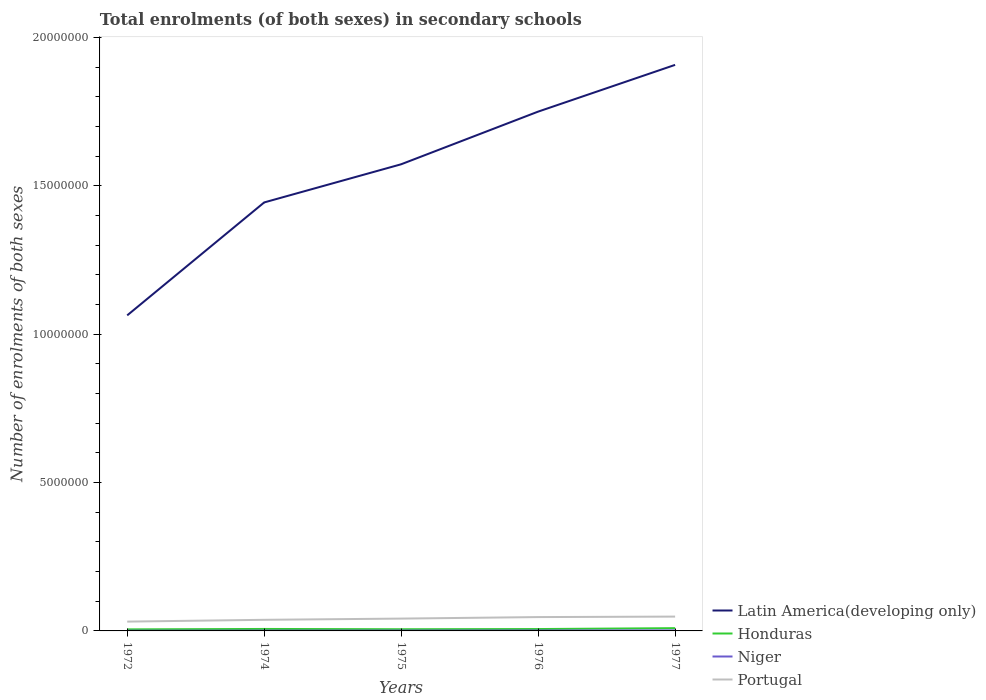How many different coloured lines are there?
Give a very brief answer. 4. Does the line corresponding to Portugal intersect with the line corresponding to Latin America(developing only)?
Offer a terse response. No. Across all years, what is the maximum number of enrolments in secondary schools in Latin America(developing only)?
Provide a short and direct response. 1.06e+07. In which year was the number of enrolments in secondary schools in Latin America(developing only) maximum?
Ensure brevity in your answer.  1972. What is the total number of enrolments in secondary schools in Niger in the graph?
Make the answer very short. -4358. What is the difference between the highest and the second highest number of enrolments in secondary schools in Niger?
Provide a short and direct response. 1.01e+04. What is the difference between the highest and the lowest number of enrolments in secondary schools in Latin America(developing only)?
Provide a short and direct response. 3. Is the number of enrolments in secondary schools in Latin America(developing only) strictly greater than the number of enrolments in secondary schools in Niger over the years?
Give a very brief answer. No. How many lines are there?
Provide a short and direct response. 4. Does the graph contain any zero values?
Give a very brief answer. No. Does the graph contain grids?
Provide a succinct answer. No. Where does the legend appear in the graph?
Provide a short and direct response. Bottom right. How are the legend labels stacked?
Provide a short and direct response. Vertical. What is the title of the graph?
Provide a short and direct response. Total enrolments (of both sexes) in secondary schools. What is the label or title of the X-axis?
Your answer should be compact. Years. What is the label or title of the Y-axis?
Provide a short and direct response. Number of enrolments of both sexes. What is the Number of enrolments of both sexes in Latin America(developing only) in 1972?
Ensure brevity in your answer.  1.06e+07. What is the Number of enrolments of both sexes of Honduras in 1972?
Offer a very short reply. 5.23e+04. What is the Number of enrolments of both sexes in Niger in 1972?
Your answer should be very brief. 7975. What is the Number of enrolments of both sexes of Portugal in 1972?
Provide a short and direct response. 3.14e+05. What is the Number of enrolments of both sexes in Latin America(developing only) in 1974?
Provide a short and direct response. 1.44e+07. What is the Number of enrolments of both sexes of Honduras in 1974?
Keep it short and to the point. 6.64e+04. What is the Number of enrolments of both sexes in Niger in 1974?
Provide a short and direct response. 1.11e+04. What is the Number of enrolments of both sexes of Portugal in 1974?
Offer a very short reply. 3.74e+05. What is the Number of enrolments of both sexes of Latin America(developing only) in 1975?
Your response must be concise. 1.57e+07. What is the Number of enrolments of both sexes of Honduras in 1975?
Make the answer very short. 5.67e+04. What is the Number of enrolments of both sexes in Niger in 1975?
Ensure brevity in your answer.  1.23e+04. What is the Number of enrolments of both sexes in Portugal in 1975?
Ensure brevity in your answer.  4.16e+05. What is the Number of enrolments of both sexes in Latin America(developing only) in 1976?
Give a very brief answer. 1.75e+07. What is the Number of enrolments of both sexes in Honduras in 1976?
Your response must be concise. 6.31e+04. What is the Number of enrolments of both sexes in Niger in 1976?
Ensure brevity in your answer.  1.45e+04. What is the Number of enrolments of both sexes in Portugal in 1976?
Ensure brevity in your answer.  4.66e+05. What is the Number of enrolments of both sexes in Latin America(developing only) in 1977?
Keep it short and to the point. 1.91e+07. What is the Number of enrolments of both sexes of Honduras in 1977?
Offer a terse response. 9.33e+04. What is the Number of enrolments of both sexes of Niger in 1977?
Your response must be concise. 1.81e+04. What is the Number of enrolments of both sexes of Portugal in 1977?
Keep it short and to the point. 4.83e+05. Across all years, what is the maximum Number of enrolments of both sexes in Latin America(developing only)?
Offer a terse response. 1.91e+07. Across all years, what is the maximum Number of enrolments of both sexes of Honduras?
Keep it short and to the point. 9.33e+04. Across all years, what is the maximum Number of enrolments of both sexes in Niger?
Provide a succinct answer. 1.81e+04. Across all years, what is the maximum Number of enrolments of both sexes in Portugal?
Provide a short and direct response. 4.83e+05. Across all years, what is the minimum Number of enrolments of both sexes of Latin America(developing only)?
Your response must be concise. 1.06e+07. Across all years, what is the minimum Number of enrolments of both sexes of Honduras?
Offer a very short reply. 5.23e+04. Across all years, what is the minimum Number of enrolments of both sexes of Niger?
Provide a succinct answer. 7975. Across all years, what is the minimum Number of enrolments of both sexes in Portugal?
Offer a terse response. 3.14e+05. What is the total Number of enrolments of both sexes in Latin America(developing only) in the graph?
Offer a very short reply. 7.74e+07. What is the total Number of enrolments of both sexes in Honduras in the graph?
Provide a succinct answer. 3.32e+05. What is the total Number of enrolments of both sexes of Niger in the graph?
Your response must be concise. 6.40e+04. What is the total Number of enrolments of both sexes of Portugal in the graph?
Your answer should be compact. 2.05e+06. What is the difference between the Number of enrolments of both sexes in Latin America(developing only) in 1972 and that in 1974?
Ensure brevity in your answer.  -3.81e+06. What is the difference between the Number of enrolments of both sexes in Honduras in 1972 and that in 1974?
Offer a terse response. -1.41e+04. What is the difference between the Number of enrolments of both sexes of Niger in 1972 and that in 1974?
Provide a succinct answer. -3133. What is the difference between the Number of enrolments of both sexes of Portugal in 1972 and that in 1974?
Ensure brevity in your answer.  -6.01e+04. What is the difference between the Number of enrolments of both sexes of Latin America(developing only) in 1972 and that in 1975?
Offer a terse response. -5.09e+06. What is the difference between the Number of enrolments of both sexes of Honduras in 1972 and that in 1975?
Offer a terse response. -4380. What is the difference between the Number of enrolments of both sexes of Niger in 1972 and that in 1975?
Your answer should be compact. -4358. What is the difference between the Number of enrolments of both sexes of Portugal in 1972 and that in 1975?
Your response must be concise. -1.02e+05. What is the difference between the Number of enrolments of both sexes in Latin America(developing only) in 1972 and that in 1976?
Your answer should be very brief. -6.87e+06. What is the difference between the Number of enrolments of both sexes of Honduras in 1972 and that in 1976?
Provide a short and direct response. -1.08e+04. What is the difference between the Number of enrolments of both sexes in Niger in 1972 and that in 1976?
Make the answer very short. -6487. What is the difference between the Number of enrolments of both sexes in Portugal in 1972 and that in 1976?
Your answer should be very brief. -1.52e+05. What is the difference between the Number of enrolments of both sexes of Latin America(developing only) in 1972 and that in 1977?
Provide a short and direct response. -8.44e+06. What is the difference between the Number of enrolments of both sexes in Honduras in 1972 and that in 1977?
Make the answer very short. -4.10e+04. What is the difference between the Number of enrolments of both sexes of Niger in 1972 and that in 1977?
Provide a short and direct response. -1.01e+04. What is the difference between the Number of enrolments of both sexes of Portugal in 1972 and that in 1977?
Your response must be concise. -1.69e+05. What is the difference between the Number of enrolments of both sexes in Latin America(developing only) in 1974 and that in 1975?
Keep it short and to the point. -1.29e+06. What is the difference between the Number of enrolments of both sexes of Honduras in 1974 and that in 1975?
Offer a terse response. 9706. What is the difference between the Number of enrolments of both sexes in Niger in 1974 and that in 1975?
Your answer should be compact. -1225. What is the difference between the Number of enrolments of both sexes in Portugal in 1974 and that in 1975?
Your answer should be very brief. -4.15e+04. What is the difference between the Number of enrolments of both sexes in Latin America(developing only) in 1974 and that in 1976?
Keep it short and to the point. -3.06e+06. What is the difference between the Number of enrolments of both sexes in Honduras in 1974 and that in 1976?
Your response must be concise. 3296. What is the difference between the Number of enrolments of both sexes of Niger in 1974 and that in 1976?
Offer a terse response. -3354. What is the difference between the Number of enrolments of both sexes in Portugal in 1974 and that in 1976?
Offer a terse response. -9.24e+04. What is the difference between the Number of enrolments of both sexes in Latin America(developing only) in 1974 and that in 1977?
Give a very brief answer. -4.64e+06. What is the difference between the Number of enrolments of both sexes of Honduras in 1974 and that in 1977?
Give a very brief answer. -2.69e+04. What is the difference between the Number of enrolments of both sexes in Niger in 1974 and that in 1977?
Offer a very short reply. -6990. What is the difference between the Number of enrolments of both sexes in Portugal in 1974 and that in 1977?
Keep it short and to the point. -1.08e+05. What is the difference between the Number of enrolments of both sexes of Latin America(developing only) in 1975 and that in 1976?
Your response must be concise. -1.77e+06. What is the difference between the Number of enrolments of both sexes of Honduras in 1975 and that in 1976?
Ensure brevity in your answer.  -6410. What is the difference between the Number of enrolments of both sexes of Niger in 1975 and that in 1976?
Provide a succinct answer. -2129. What is the difference between the Number of enrolments of both sexes of Portugal in 1975 and that in 1976?
Offer a very short reply. -5.08e+04. What is the difference between the Number of enrolments of both sexes in Latin America(developing only) in 1975 and that in 1977?
Your answer should be compact. -3.35e+06. What is the difference between the Number of enrolments of both sexes of Honduras in 1975 and that in 1977?
Offer a terse response. -3.66e+04. What is the difference between the Number of enrolments of both sexes of Niger in 1975 and that in 1977?
Ensure brevity in your answer.  -5765. What is the difference between the Number of enrolments of both sexes of Portugal in 1975 and that in 1977?
Ensure brevity in your answer.  -6.69e+04. What is the difference between the Number of enrolments of both sexes of Latin America(developing only) in 1976 and that in 1977?
Your response must be concise. -1.58e+06. What is the difference between the Number of enrolments of both sexes of Honduras in 1976 and that in 1977?
Your response must be concise. -3.02e+04. What is the difference between the Number of enrolments of both sexes of Niger in 1976 and that in 1977?
Ensure brevity in your answer.  -3636. What is the difference between the Number of enrolments of both sexes in Portugal in 1976 and that in 1977?
Provide a succinct answer. -1.61e+04. What is the difference between the Number of enrolments of both sexes of Latin America(developing only) in 1972 and the Number of enrolments of both sexes of Honduras in 1974?
Make the answer very short. 1.06e+07. What is the difference between the Number of enrolments of both sexes in Latin America(developing only) in 1972 and the Number of enrolments of both sexes in Niger in 1974?
Provide a succinct answer. 1.06e+07. What is the difference between the Number of enrolments of both sexes of Latin America(developing only) in 1972 and the Number of enrolments of both sexes of Portugal in 1974?
Keep it short and to the point. 1.03e+07. What is the difference between the Number of enrolments of both sexes in Honduras in 1972 and the Number of enrolments of both sexes in Niger in 1974?
Keep it short and to the point. 4.12e+04. What is the difference between the Number of enrolments of both sexes of Honduras in 1972 and the Number of enrolments of both sexes of Portugal in 1974?
Make the answer very short. -3.22e+05. What is the difference between the Number of enrolments of both sexes of Niger in 1972 and the Number of enrolments of both sexes of Portugal in 1974?
Give a very brief answer. -3.66e+05. What is the difference between the Number of enrolments of both sexes of Latin America(developing only) in 1972 and the Number of enrolments of both sexes of Honduras in 1975?
Your answer should be very brief. 1.06e+07. What is the difference between the Number of enrolments of both sexes of Latin America(developing only) in 1972 and the Number of enrolments of both sexes of Niger in 1975?
Your answer should be very brief. 1.06e+07. What is the difference between the Number of enrolments of both sexes in Latin America(developing only) in 1972 and the Number of enrolments of both sexes in Portugal in 1975?
Provide a succinct answer. 1.02e+07. What is the difference between the Number of enrolments of both sexes of Honduras in 1972 and the Number of enrolments of both sexes of Niger in 1975?
Your response must be concise. 4.00e+04. What is the difference between the Number of enrolments of both sexes of Honduras in 1972 and the Number of enrolments of both sexes of Portugal in 1975?
Provide a succinct answer. -3.63e+05. What is the difference between the Number of enrolments of both sexes of Niger in 1972 and the Number of enrolments of both sexes of Portugal in 1975?
Provide a succinct answer. -4.08e+05. What is the difference between the Number of enrolments of both sexes in Latin America(developing only) in 1972 and the Number of enrolments of both sexes in Honduras in 1976?
Your answer should be very brief. 1.06e+07. What is the difference between the Number of enrolments of both sexes in Latin America(developing only) in 1972 and the Number of enrolments of both sexes in Niger in 1976?
Your answer should be very brief. 1.06e+07. What is the difference between the Number of enrolments of both sexes of Latin America(developing only) in 1972 and the Number of enrolments of both sexes of Portugal in 1976?
Keep it short and to the point. 1.02e+07. What is the difference between the Number of enrolments of both sexes in Honduras in 1972 and the Number of enrolments of both sexes in Niger in 1976?
Offer a very short reply. 3.79e+04. What is the difference between the Number of enrolments of both sexes of Honduras in 1972 and the Number of enrolments of both sexes of Portugal in 1976?
Make the answer very short. -4.14e+05. What is the difference between the Number of enrolments of both sexes of Niger in 1972 and the Number of enrolments of both sexes of Portugal in 1976?
Your answer should be very brief. -4.59e+05. What is the difference between the Number of enrolments of both sexes in Latin America(developing only) in 1972 and the Number of enrolments of both sexes in Honduras in 1977?
Offer a very short reply. 1.05e+07. What is the difference between the Number of enrolments of both sexes in Latin America(developing only) in 1972 and the Number of enrolments of both sexes in Niger in 1977?
Make the answer very short. 1.06e+07. What is the difference between the Number of enrolments of both sexes in Latin America(developing only) in 1972 and the Number of enrolments of both sexes in Portugal in 1977?
Keep it short and to the point. 1.02e+07. What is the difference between the Number of enrolments of both sexes in Honduras in 1972 and the Number of enrolments of both sexes in Niger in 1977?
Make the answer very short. 3.42e+04. What is the difference between the Number of enrolments of both sexes of Honduras in 1972 and the Number of enrolments of both sexes of Portugal in 1977?
Your answer should be compact. -4.30e+05. What is the difference between the Number of enrolments of both sexes of Niger in 1972 and the Number of enrolments of both sexes of Portugal in 1977?
Give a very brief answer. -4.75e+05. What is the difference between the Number of enrolments of both sexes in Latin America(developing only) in 1974 and the Number of enrolments of both sexes in Honduras in 1975?
Provide a succinct answer. 1.44e+07. What is the difference between the Number of enrolments of both sexes of Latin America(developing only) in 1974 and the Number of enrolments of both sexes of Niger in 1975?
Your answer should be very brief. 1.44e+07. What is the difference between the Number of enrolments of both sexes of Latin America(developing only) in 1974 and the Number of enrolments of both sexes of Portugal in 1975?
Make the answer very short. 1.40e+07. What is the difference between the Number of enrolments of both sexes of Honduras in 1974 and the Number of enrolments of both sexes of Niger in 1975?
Offer a terse response. 5.41e+04. What is the difference between the Number of enrolments of both sexes of Honduras in 1974 and the Number of enrolments of both sexes of Portugal in 1975?
Your answer should be very brief. -3.49e+05. What is the difference between the Number of enrolments of both sexes in Niger in 1974 and the Number of enrolments of both sexes in Portugal in 1975?
Offer a terse response. -4.05e+05. What is the difference between the Number of enrolments of both sexes in Latin America(developing only) in 1974 and the Number of enrolments of both sexes in Honduras in 1976?
Your answer should be compact. 1.44e+07. What is the difference between the Number of enrolments of both sexes of Latin America(developing only) in 1974 and the Number of enrolments of both sexes of Niger in 1976?
Offer a very short reply. 1.44e+07. What is the difference between the Number of enrolments of both sexes in Latin America(developing only) in 1974 and the Number of enrolments of both sexes in Portugal in 1976?
Offer a very short reply. 1.40e+07. What is the difference between the Number of enrolments of both sexes of Honduras in 1974 and the Number of enrolments of both sexes of Niger in 1976?
Provide a short and direct response. 5.19e+04. What is the difference between the Number of enrolments of both sexes of Honduras in 1974 and the Number of enrolments of both sexes of Portugal in 1976?
Provide a short and direct response. -4.00e+05. What is the difference between the Number of enrolments of both sexes of Niger in 1974 and the Number of enrolments of both sexes of Portugal in 1976?
Ensure brevity in your answer.  -4.55e+05. What is the difference between the Number of enrolments of both sexes in Latin America(developing only) in 1974 and the Number of enrolments of both sexes in Honduras in 1977?
Make the answer very short. 1.43e+07. What is the difference between the Number of enrolments of both sexes in Latin America(developing only) in 1974 and the Number of enrolments of both sexes in Niger in 1977?
Your answer should be compact. 1.44e+07. What is the difference between the Number of enrolments of both sexes of Latin America(developing only) in 1974 and the Number of enrolments of both sexes of Portugal in 1977?
Your response must be concise. 1.40e+07. What is the difference between the Number of enrolments of both sexes of Honduras in 1974 and the Number of enrolments of both sexes of Niger in 1977?
Your response must be concise. 4.83e+04. What is the difference between the Number of enrolments of both sexes in Honduras in 1974 and the Number of enrolments of both sexes in Portugal in 1977?
Your response must be concise. -4.16e+05. What is the difference between the Number of enrolments of both sexes in Niger in 1974 and the Number of enrolments of both sexes in Portugal in 1977?
Give a very brief answer. -4.71e+05. What is the difference between the Number of enrolments of both sexes in Latin America(developing only) in 1975 and the Number of enrolments of both sexes in Honduras in 1976?
Provide a short and direct response. 1.57e+07. What is the difference between the Number of enrolments of both sexes of Latin America(developing only) in 1975 and the Number of enrolments of both sexes of Niger in 1976?
Keep it short and to the point. 1.57e+07. What is the difference between the Number of enrolments of both sexes of Latin America(developing only) in 1975 and the Number of enrolments of both sexes of Portugal in 1976?
Keep it short and to the point. 1.53e+07. What is the difference between the Number of enrolments of both sexes in Honduras in 1975 and the Number of enrolments of both sexes in Niger in 1976?
Offer a terse response. 4.22e+04. What is the difference between the Number of enrolments of both sexes of Honduras in 1975 and the Number of enrolments of both sexes of Portugal in 1976?
Your response must be concise. -4.10e+05. What is the difference between the Number of enrolments of both sexes of Niger in 1975 and the Number of enrolments of both sexes of Portugal in 1976?
Ensure brevity in your answer.  -4.54e+05. What is the difference between the Number of enrolments of both sexes in Latin America(developing only) in 1975 and the Number of enrolments of both sexes in Honduras in 1977?
Keep it short and to the point. 1.56e+07. What is the difference between the Number of enrolments of both sexes in Latin America(developing only) in 1975 and the Number of enrolments of both sexes in Niger in 1977?
Offer a very short reply. 1.57e+07. What is the difference between the Number of enrolments of both sexes in Latin America(developing only) in 1975 and the Number of enrolments of both sexes in Portugal in 1977?
Your response must be concise. 1.52e+07. What is the difference between the Number of enrolments of both sexes of Honduras in 1975 and the Number of enrolments of both sexes of Niger in 1977?
Your answer should be compact. 3.86e+04. What is the difference between the Number of enrolments of both sexes in Honduras in 1975 and the Number of enrolments of both sexes in Portugal in 1977?
Your response must be concise. -4.26e+05. What is the difference between the Number of enrolments of both sexes in Niger in 1975 and the Number of enrolments of both sexes in Portugal in 1977?
Make the answer very short. -4.70e+05. What is the difference between the Number of enrolments of both sexes in Latin America(developing only) in 1976 and the Number of enrolments of both sexes in Honduras in 1977?
Ensure brevity in your answer.  1.74e+07. What is the difference between the Number of enrolments of both sexes in Latin America(developing only) in 1976 and the Number of enrolments of both sexes in Niger in 1977?
Your answer should be very brief. 1.75e+07. What is the difference between the Number of enrolments of both sexes of Latin America(developing only) in 1976 and the Number of enrolments of both sexes of Portugal in 1977?
Your answer should be compact. 1.70e+07. What is the difference between the Number of enrolments of both sexes of Honduras in 1976 and the Number of enrolments of both sexes of Niger in 1977?
Ensure brevity in your answer.  4.50e+04. What is the difference between the Number of enrolments of both sexes in Honduras in 1976 and the Number of enrolments of both sexes in Portugal in 1977?
Provide a succinct answer. -4.19e+05. What is the difference between the Number of enrolments of both sexes of Niger in 1976 and the Number of enrolments of both sexes of Portugal in 1977?
Offer a terse response. -4.68e+05. What is the average Number of enrolments of both sexes in Latin America(developing only) per year?
Provide a succinct answer. 1.55e+07. What is the average Number of enrolments of both sexes of Honduras per year?
Your answer should be compact. 6.64e+04. What is the average Number of enrolments of both sexes in Niger per year?
Offer a very short reply. 1.28e+04. What is the average Number of enrolments of both sexes of Portugal per year?
Ensure brevity in your answer.  4.11e+05. In the year 1972, what is the difference between the Number of enrolments of both sexes in Latin America(developing only) and Number of enrolments of both sexes in Honduras?
Offer a terse response. 1.06e+07. In the year 1972, what is the difference between the Number of enrolments of both sexes of Latin America(developing only) and Number of enrolments of both sexes of Niger?
Provide a succinct answer. 1.06e+07. In the year 1972, what is the difference between the Number of enrolments of both sexes of Latin America(developing only) and Number of enrolments of both sexes of Portugal?
Your response must be concise. 1.03e+07. In the year 1972, what is the difference between the Number of enrolments of both sexes in Honduras and Number of enrolments of both sexes in Niger?
Offer a very short reply. 4.44e+04. In the year 1972, what is the difference between the Number of enrolments of both sexes of Honduras and Number of enrolments of both sexes of Portugal?
Your answer should be compact. -2.62e+05. In the year 1972, what is the difference between the Number of enrolments of both sexes of Niger and Number of enrolments of both sexes of Portugal?
Keep it short and to the point. -3.06e+05. In the year 1974, what is the difference between the Number of enrolments of both sexes of Latin America(developing only) and Number of enrolments of both sexes of Honduras?
Offer a terse response. 1.44e+07. In the year 1974, what is the difference between the Number of enrolments of both sexes in Latin America(developing only) and Number of enrolments of both sexes in Niger?
Your response must be concise. 1.44e+07. In the year 1974, what is the difference between the Number of enrolments of both sexes of Latin America(developing only) and Number of enrolments of both sexes of Portugal?
Provide a succinct answer. 1.41e+07. In the year 1974, what is the difference between the Number of enrolments of both sexes of Honduras and Number of enrolments of both sexes of Niger?
Offer a terse response. 5.53e+04. In the year 1974, what is the difference between the Number of enrolments of both sexes in Honduras and Number of enrolments of both sexes in Portugal?
Ensure brevity in your answer.  -3.08e+05. In the year 1974, what is the difference between the Number of enrolments of both sexes in Niger and Number of enrolments of both sexes in Portugal?
Provide a short and direct response. -3.63e+05. In the year 1975, what is the difference between the Number of enrolments of both sexes of Latin America(developing only) and Number of enrolments of both sexes of Honduras?
Your answer should be compact. 1.57e+07. In the year 1975, what is the difference between the Number of enrolments of both sexes in Latin America(developing only) and Number of enrolments of both sexes in Niger?
Give a very brief answer. 1.57e+07. In the year 1975, what is the difference between the Number of enrolments of both sexes of Latin America(developing only) and Number of enrolments of both sexes of Portugal?
Give a very brief answer. 1.53e+07. In the year 1975, what is the difference between the Number of enrolments of both sexes in Honduras and Number of enrolments of both sexes in Niger?
Your answer should be very brief. 4.44e+04. In the year 1975, what is the difference between the Number of enrolments of both sexes of Honduras and Number of enrolments of both sexes of Portugal?
Ensure brevity in your answer.  -3.59e+05. In the year 1975, what is the difference between the Number of enrolments of both sexes of Niger and Number of enrolments of both sexes of Portugal?
Your answer should be compact. -4.03e+05. In the year 1976, what is the difference between the Number of enrolments of both sexes of Latin America(developing only) and Number of enrolments of both sexes of Honduras?
Your answer should be compact. 1.74e+07. In the year 1976, what is the difference between the Number of enrolments of both sexes of Latin America(developing only) and Number of enrolments of both sexes of Niger?
Your response must be concise. 1.75e+07. In the year 1976, what is the difference between the Number of enrolments of both sexes in Latin America(developing only) and Number of enrolments of both sexes in Portugal?
Make the answer very short. 1.70e+07. In the year 1976, what is the difference between the Number of enrolments of both sexes of Honduras and Number of enrolments of both sexes of Niger?
Make the answer very short. 4.87e+04. In the year 1976, what is the difference between the Number of enrolments of both sexes of Honduras and Number of enrolments of both sexes of Portugal?
Provide a short and direct response. -4.03e+05. In the year 1976, what is the difference between the Number of enrolments of both sexes of Niger and Number of enrolments of both sexes of Portugal?
Give a very brief answer. -4.52e+05. In the year 1977, what is the difference between the Number of enrolments of both sexes in Latin America(developing only) and Number of enrolments of both sexes in Honduras?
Offer a terse response. 1.90e+07. In the year 1977, what is the difference between the Number of enrolments of both sexes of Latin America(developing only) and Number of enrolments of both sexes of Niger?
Offer a terse response. 1.91e+07. In the year 1977, what is the difference between the Number of enrolments of both sexes of Latin America(developing only) and Number of enrolments of both sexes of Portugal?
Keep it short and to the point. 1.86e+07. In the year 1977, what is the difference between the Number of enrolments of both sexes of Honduras and Number of enrolments of both sexes of Niger?
Provide a succinct answer. 7.52e+04. In the year 1977, what is the difference between the Number of enrolments of both sexes in Honduras and Number of enrolments of both sexes in Portugal?
Make the answer very short. -3.89e+05. In the year 1977, what is the difference between the Number of enrolments of both sexes of Niger and Number of enrolments of both sexes of Portugal?
Provide a succinct answer. -4.64e+05. What is the ratio of the Number of enrolments of both sexes in Latin America(developing only) in 1972 to that in 1974?
Your response must be concise. 0.74. What is the ratio of the Number of enrolments of both sexes of Honduras in 1972 to that in 1974?
Your answer should be compact. 0.79. What is the ratio of the Number of enrolments of both sexes in Niger in 1972 to that in 1974?
Ensure brevity in your answer.  0.72. What is the ratio of the Number of enrolments of both sexes of Portugal in 1972 to that in 1974?
Your answer should be very brief. 0.84. What is the ratio of the Number of enrolments of both sexes in Latin America(developing only) in 1972 to that in 1975?
Offer a terse response. 0.68. What is the ratio of the Number of enrolments of both sexes in Honduras in 1972 to that in 1975?
Offer a terse response. 0.92. What is the ratio of the Number of enrolments of both sexes of Niger in 1972 to that in 1975?
Keep it short and to the point. 0.65. What is the ratio of the Number of enrolments of both sexes in Portugal in 1972 to that in 1975?
Offer a very short reply. 0.76. What is the ratio of the Number of enrolments of both sexes in Latin America(developing only) in 1972 to that in 1976?
Offer a terse response. 0.61. What is the ratio of the Number of enrolments of both sexes in Honduras in 1972 to that in 1976?
Ensure brevity in your answer.  0.83. What is the ratio of the Number of enrolments of both sexes in Niger in 1972 to that in 1976?
Ensure brevity in your answer.  0.55. What is the ratio of the Number of enrolments of both sexes in Portugal in 1972 to that in 1976?
Your answer should be compact. 0.67. What is the ratio of the Number of enrolments of both sexes of Latin America(developing only) in 1972 to that in 1977?
Give a very brief answer. 0.56. What is the ratio of the Number of enrolments of both sexes of Honduras in 1972 to that in 1977?
Your response must be concise. 0.56. What is the ratio of the Number of enrolments of both sexes of Niger in 1972 to that in 1977?
Offer a terse response. 0.44. What is the ratio of the Number of enrolments of both sexes of Portugal in 1972 to that in 1977?
Make the answer very short. 0.65. What is the ratio of the Number of enrolments of both sexes of Latin America(developing only) in 1974 to that in 1975?
Your answer should be compact. 0.92. What is the ratio of the Number of enrolments of both sexes in Honduras in 1974 to that in 1975?
Offer a terse response. 1.17. What is the ratio of the Number of enrolments of both sexes of Niger in 1974 to that in 1975?
Make the answer very short. 0.9. What is the ratio of the Number of enrolments of both sexes of Portugal in 1974 to that in 1975?
Make the answer very short. 0.9. What is the ratio of the Number of enrolments of both sexes in Latin America(developing only) in 1974 to that in 1976?
Ensure brevity in your answer.  0.83. What is the ratio of the Number of enrolments of both sexes of Honduras in 1974 to that in 1976?
Offer a very short reply. 1.05. What is the ratio of the Number of enrolments of both sexes of Niger in 1974 to that in 1976?
Your answer should be very brief. 0.77. What is the ratio of the Number of enrolments of both sexes in Portugal in 1974 to that in 1976?
Your response must be concise. 0.8. What is the ratio of the Number of enrolments of both sexes in Latin America(developing only) in 1974 to that in 1977?
Give a very brief answer. 0.76. What is the ratio of the Number of enrolments of both sexes in Honduras in 1974 to that in 1977?
Your answer should be very brief. 0.71. What is the ratio of the Number of enrolments of both sexes of Niger in 1974 to that in 1977?
Offer a terse response. 0.61. What is the ratio of the Number of enrolments of both sexes of Portugal in 1974 to that in 1977?
Ensure brevity in your answer.  0.78. What is the ratio of the Number of enrolments of both sexes of Latin America(developing only) in 1975 to that in 1976?
Your response must be concise. 0.9. What is the ratio of the Number of enrolments of both sexes of Honduras in 1975 to that in 1976?
Your answer should be compact. 0.9. What is the ratio of the Number of enrolments of both sexes in Niger in 1975 to that in 1976?
Offer a very short reply. 0.85. What is the ratio of the Number of enrolments of both sexes in Portugal in 1975 to that in 1976?
Your answer should be very brief. 0.89. What is the ratio of the Number of enrolments of both sexes of Latin America(developing only) in 1975 to that in 1977?
Keep it short and to the point. 0.82. What is the ratio of the Number of enrolments of both sexes of Honduras in 1975 to that in 1977?
Provide a short and direct response. 0.61. What is the ratio of the Number of enrolments of both sexes of Niger in 1975 to that in 1977?
Make the answer very short. 0.68. What is the ratio of the Number of enrolments of both sexes of Portugal in 1975 to that in 1977?
Offer a very short reply. 0.86. What is the ratio of the Number of enrolments of both sexes of Latin America(developing only) in 1976 to that in 1977?
Offer a very short reply. 0.92. What is the ratio of the Number of enrolments of both sexes in Honduras in 1976 to that in 1977?
Provide a succinct answer. 0.68. What is the ratio of the Number of enrolments of both sexes of Niger in 1976 to that in 1977?
Ensure brevity in your answer.  0.8. What is the ratio of the Number of enrolments of both sexes in Portugal in 1976 to that in 1977?
Make the answer very short. 0.97. What is the difference between the highest and the second highest Number of enrolments of both sexes in Latin America(developing only)?
Offer a very short reply. 1.58e+06. What is the difference between the highest and the second highest Number of enrolments of both sexes of Honduras?
Provide a short and direct response. 2.69e+04. What is the difference between the highest and the second highest Number of enrolments of both sexes of Niger?
Provide a short and direct response. 3636. What is the difference between the highest and the second highest Number of enrolments of both sexes of Portugal?
Give a very brief answer. 1.61e+04. What is the difference between the highest and the lowest Number of enrolments of both sexes of Latin America(developing only)?
Ensure brevity in your answer.  8.44e+06. What is the difference between the highest and the lowest Number of enrolments of both sexes of Honduras?
Offer a terse response. 4.10e+04. What is the difference between the highest and the lowest Number of enrolments of both sexes in Niger?
Keep it short and to the point. 1.01e+04. What is the difference between the highest and the lowest Number of enrolments of both sexes in Portugal?
Provide a short and direct response. 1.69e+05. 